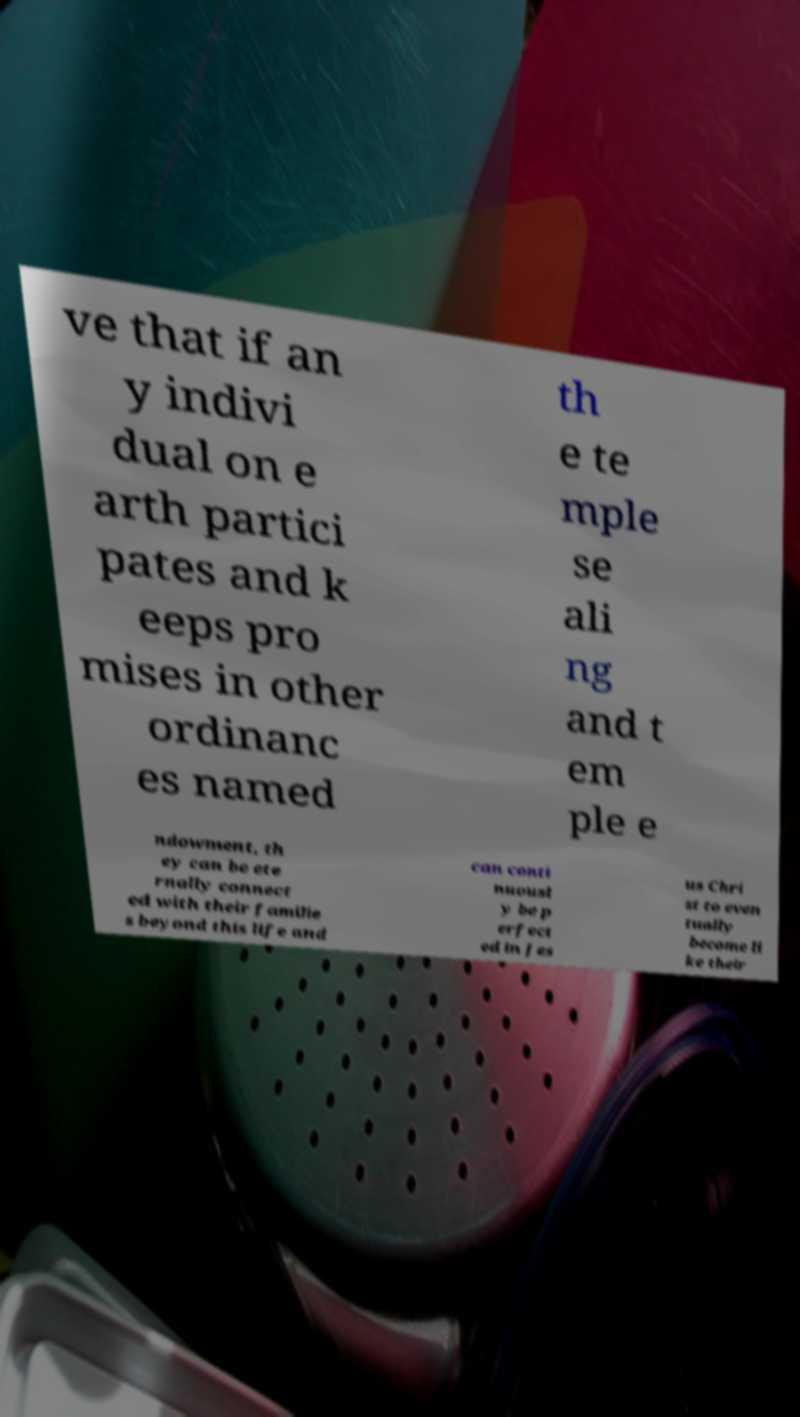What messages or text are displayed in this image? I need them in a readable, typed format. ve that if an y indivi dual on e arth partici pates and k eeps pro mises in other ordinanc es named th e te mple se ali ng and t em ple e ndowment, th ey can be ete rnally connect ed with their familie s beyond this life and can conti nuousl y be p erfect ed in Jes us Chri st to even tually become li ke their 